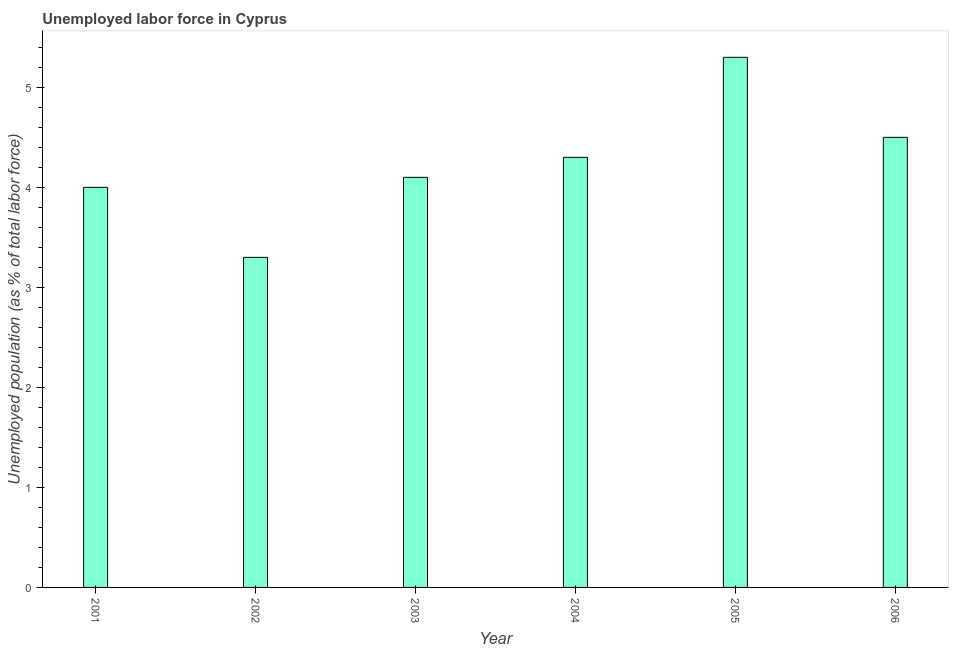Does the graph contain any zero values?
Give a very brief answer. No. What is the title of the graph?
Your answer should be very brief. Unemployed labor force in Cyprus. What is the label or title of the X-axis?
Provide a succinct answer. Year. What is the label or title of the Y-axis?
Provide a succinct answer. Unemployed population (as % of total labor force). What is the total unemployed population in 2004?
Provide a succinct answer. 4.3. Across all years, what is the maximum total unemployed population?
Make the answer very short. 5.3. Across all years, what is the minimum total unemployed population?
Ensure brevity in your answer.  3.3. In which year was the total unemployed population minimum?
Provide a short and direct response. 2002. What is the sum of the total unemployed population?
Your response must be concise. 25.5. What is the average total unemployed population per year?
Keep it short and to the point. 4.25. What is the median total unemployed population?
Offer a very short reply. 4.2. In how many years, is the total unemployed population greater than 2.4 %?
Ensure brevity in your answer.  6. Do a majority of the years between 2001 and 2004 (inclusive) have total unemployed population greater than 1.6 %?
Provide a short and direct response. Yes. What is the ratio of the total unemployed population in 2003 to that in 2006?
Your answer should be very brief. 0.91. Is the difference between the total unemployed population in 2001 and 2002 greater than the difference between any two years?
Your answer should be very brief. No. Is the sum of the total unemployed population in 2001 and 2002 greater than the maximum total unemployed population across all years?
Ensure brevity in your answer.  Yes. In how many years, is the total unemployed population greater than the average total unemployed population taken over all years?
Your response must be concise. 3. Are all the bars in the graph horizontal?
Keep it short and to the point. No. What is the difference between two consecutive major ticks on the Y-axis?
Provide a short and direct response. 1. Are the values on the major ticks of Y-axis written in scientific E-notation?
Provide a succinct answer. No. What is the Unemployed population (as % of total labor force) of 2001?
Offer a terse response. 4. What is the Unemployed population (as % of total labor force) in 2002?
Make the answer very short. 3.3. What is the Unemployed population (as % of total labor force) of 2003?
Ensure brevity in your answer.  4.1. What is the Unemployed population (as % of total labor force) in 2004?
Provide a short and direct response. 4.3. What is the Unemployed population (as % of total labor force) of 2005?
Offer a terse response. 5.3. What is the Unemployed population (as % of total labor force) in 2006?
Offer a very short reply. 4.5. What is the difference between the Unemployed population (as % of total labor force) in 2001 and 2002?
Offer a terse response. 0.7. What is the difference between the Unemployed population (as % of total labor force) in 2001 and 2006?
Make the answer very short. -0.5. What is the difference between the Unemployed population (as % of total labor force) in 2003 and 2004?
Offer a very short reply. -0.2. What is the difference between the Unemployed population (as % of total labor force) in 2004 and 2005?
Give a very brief answer. -1. What is the difference between the Unemployed population (as % of total labor force) in 2004 and 2006?
Make the answer very short. -0.2. What is the ratio of the Unemployed population (as % of total labor force) in 2001 to that in 2002?
Give a very brief answer. 1.21. What is the ratio of the Unemployed population (as % of total labor force) in 2001 to that in 2003?
Give a very brief answer. 0.98. What is the ratio of the Unemployed population (as % of total labor force) in 2001 to that in 2004?
Make the answer very short. 0.93. What is the ratio of the Unemployed population (as % of total labor force) in 2001 to that in 2005?
Your answer should be very brief. 0.76. What is the ratio of the Unemployed population (as % of total labor force) in 2001 to that in 2006?
Offer a very short reply. 0.89. What is the ratio of the Unemployed population (as % of total labor force) in 2002 to that in 2003?
Your response must be concise. 0.81. What is the ratio of the Unemployed population (as % of total labor force) in 2002 to that in 2004?
Give a very brief answer. 0.77. What is the ratio of the Unemployed population (as % of total labor force) in 2002 to that in 2005?
Offer a terse response. 0.62. What is the ratio of the Unemployed population (as % of total labor force) in 2002 to that in 2006?
Your answer should be very brief. 0.73. What is the ratio of the Unemployed population (as % of total labor force) in 2003 to that in 2004?
Offer a terse response. 0.95. What is the ratio of the Unemployed population (as % of total labor force) in 2003 to that in 2005?
Your answer should be very brief. 0.77. What is the ratio of the Unemployed population (as % of total labor force) in 2003 to that in 2006?
Ensure brevity in your answer.  0.91. What is the ratio of the Unemployed population (as % of total labor force) in 2004 to that in 2005?
Offer a terse response. 0.81. What is the ratio of the Unemployed population (as % of total labor force) in 2004 to that in 2006?
Ensure brevity in your answer.  0.96. What is the ratio of the Unemployed population (as % of total labor force) in 2005 to that in 2006?
Keep it short and to the point. 1.18. 